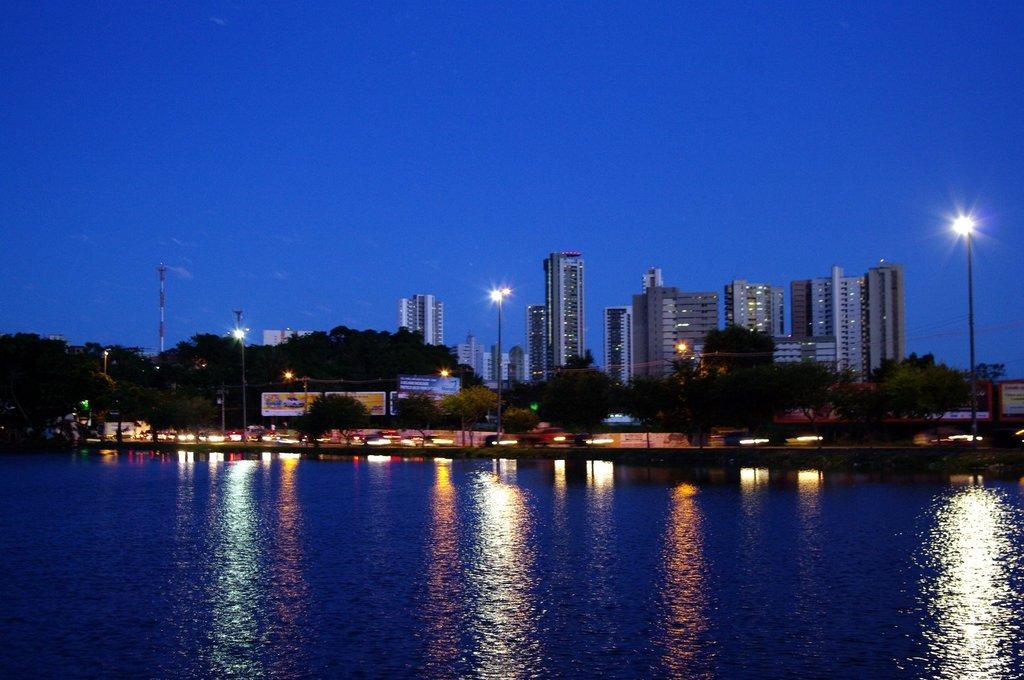Describe this image in one or two sentences. This is the picture of a city. In this image there are buildings and trees and there are street lights and there is a tower and there are hoardings and there is text on the hoardings and there are vehicles on the road. At the top there is sky. At the bottom there is water. 